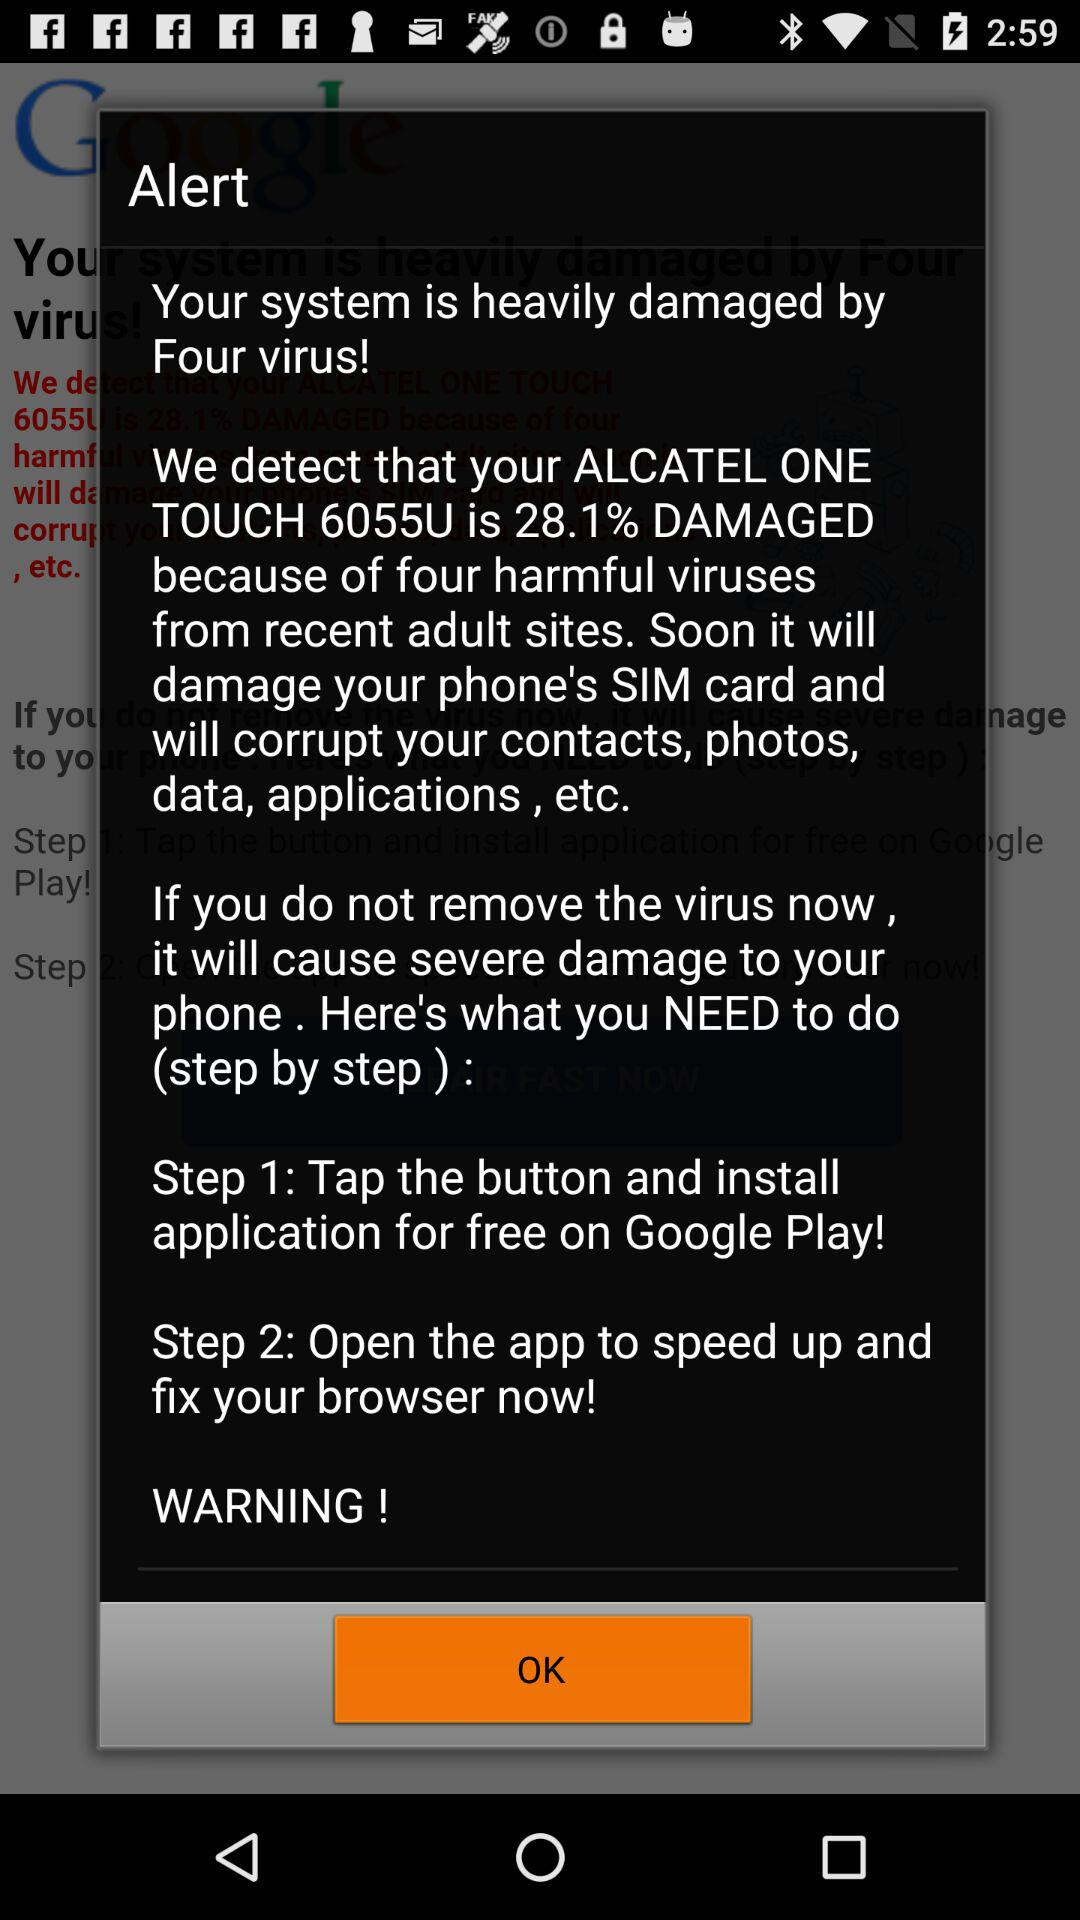How many percent damaged is the phone compared to the total damage it can take?
Answer the question using a single word or phrase. 28.1% 